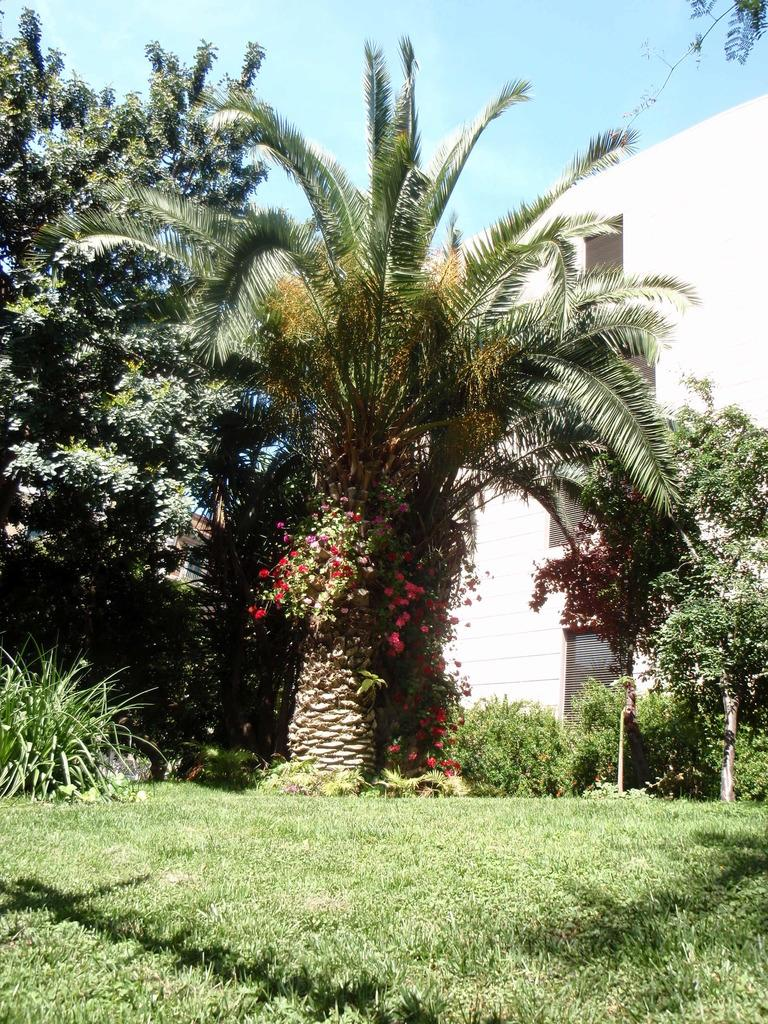Where was the picture taken? The picture was clicked outside. What can be seen in the foreground of the image? There is green grass and plants in the foreground of the image. What is located in the center of the image? There are trees and a building in the center of the image. What is visible in the background of the image? The sky is visible in the background of the image. What type of meal is being prepared in the image? There is no meal preparation visible in the image; it features an outdoor scene with green grass, plants, trees, a building, and the sky. 